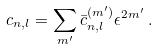Convert formula to latex. <formula><loc_0><loc_0><loc_500><loc_500>c _ { n , l } = \sum _ { m ^ { \prime } } \bar { c } _ { n , l } ^ { ( m ^ { \prime } ) } \epsilon ^ { 2 m ^ { \prime } } \, .</formula> 